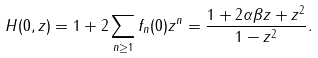Convert formula to latex. <formula><loc_0><loc_0><loc_500><loc_500>H ( 0 , z ) = 1 + 2 \sum _ { n \geq 1 } f _ { n } ( 0 ) z ^ { n } = \frac { 1 + 2 \alpha \beta z + z ^ { 2 } } { 1 - z ^ { 2 } } .</formula> 